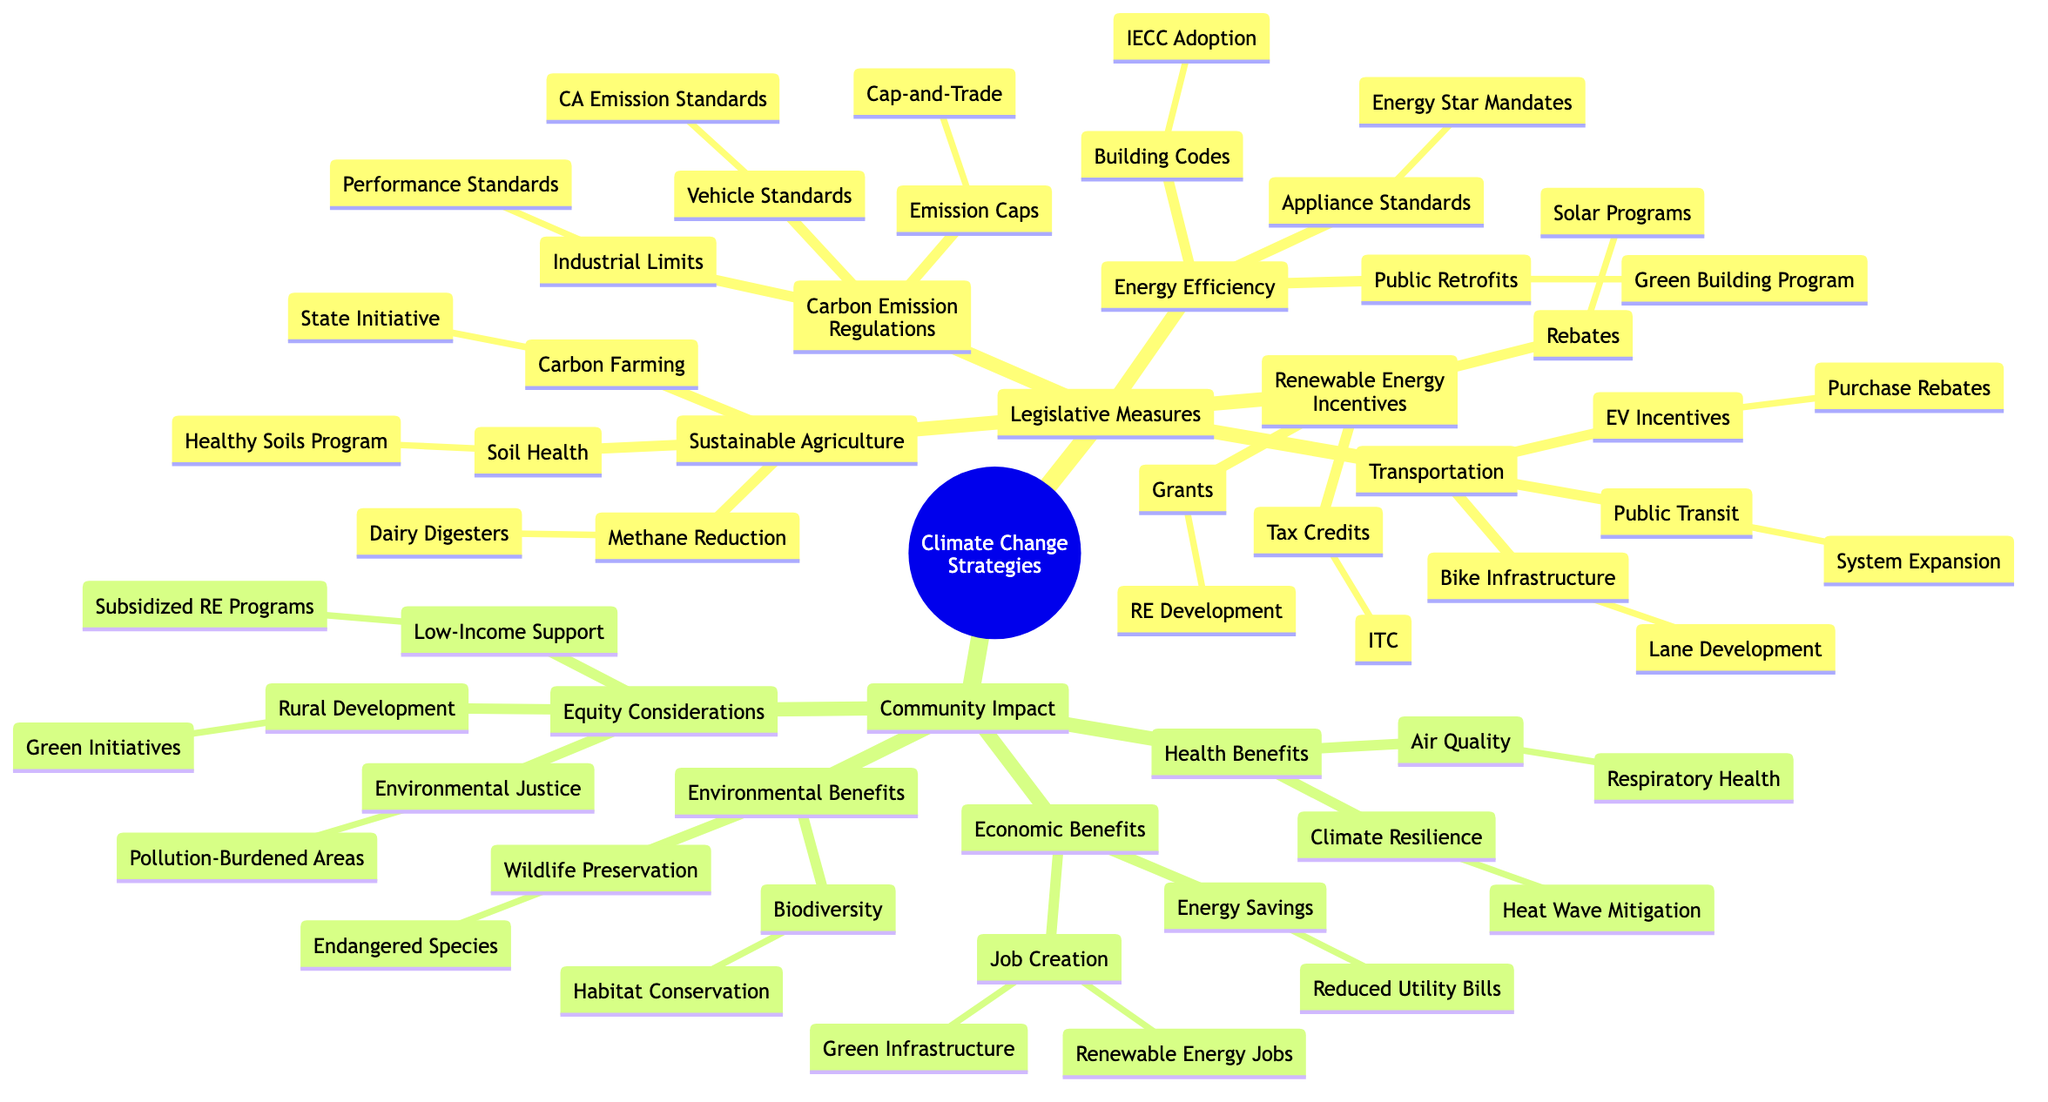What legislative measure includes tax credits? The diagram indicates that "Renewable Energy Incentives" is a legislative measure with "Tax Credits" listed as a subcategory under it.
Answer: Renewable Energy Incentives How many main categories are there under Legislative Measures? By counting in the diagram, there are five main categories listed under Legislative Measures: Renewable Energy Incentives, Carbon Emission Regulations, Sustainable Agriculture, Energy Efficiency Programs, and Transportation Improvements.
Answer: 5 What program aims to support low-income communities? The diagram states that there's a focus on providing support for low-income communities through "Subsidized Renewable Energy Programs," which falls under the Equity Considerations section of Community Impact.
Answer: Subsidized Renewable Energy Programs What is one economic benefit related to job creation? Under the Economic Benefits section, the diagram lists "Renewable Energy Sector" as one of the points relating to job creation, clearly indicating the link between job opportunities and renewable energy.
Answer: Renewable Energy Sector How many types of transportation improvements are listed? A quick count of the nodes under Transportation Improvements reveals three types: Public Transit Expansion, Electric Vehicle Incentives, and Bike Infrastructure.
Answer: 3 What is a health benefit related to air quality? The diagram mentions that one of the health benefits is the "Reduction in Respiratory Diseases," which is specifically listed under the Health Benefits section of Community Impact.
Answer: Reduction in Respiratory Diseases What initiative supports dairy methane reduction? The diagram indicates that the "Dairy Digester Development Program" is the initiative related to agricultural methane reduction in the Sustainable Agriculture category.
Answer: Dairy Digester Development Program Which section addresses climate resilience? The diagram clearly places "Climate Resilience" within the Health Benefits section, demonstrating that this aspect is recognized as part of public health improvements driven by climate change strategies.
Answer: Health Benefits What type of legislative measure involves emission caps? The diagram categorizes "Emission Caps" under "Carbon Emission Regulations," highlighting its relationship with legislative actions aimed at controlling emissions.
Answer: Carbon Emission Regulations 